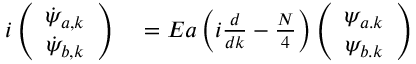<formula> <loc_0><loc_0><loc_500><loc_500>\begin{array} { r l } { i \left ( \begin{array} { c } { \dot { \psi } _ { a , k } } \\ { \dot { \psi } _ { b , k } } \end{array} \right ) } & = E a \left ( i \frac { d } { d k } - \frac { N } { 4 } \right ) \left ( \begin{array} { c } { \psi _ { a . k } } \\ { \psi _ { b . k } } \end{array} \right ) } \end{array}</formula> 